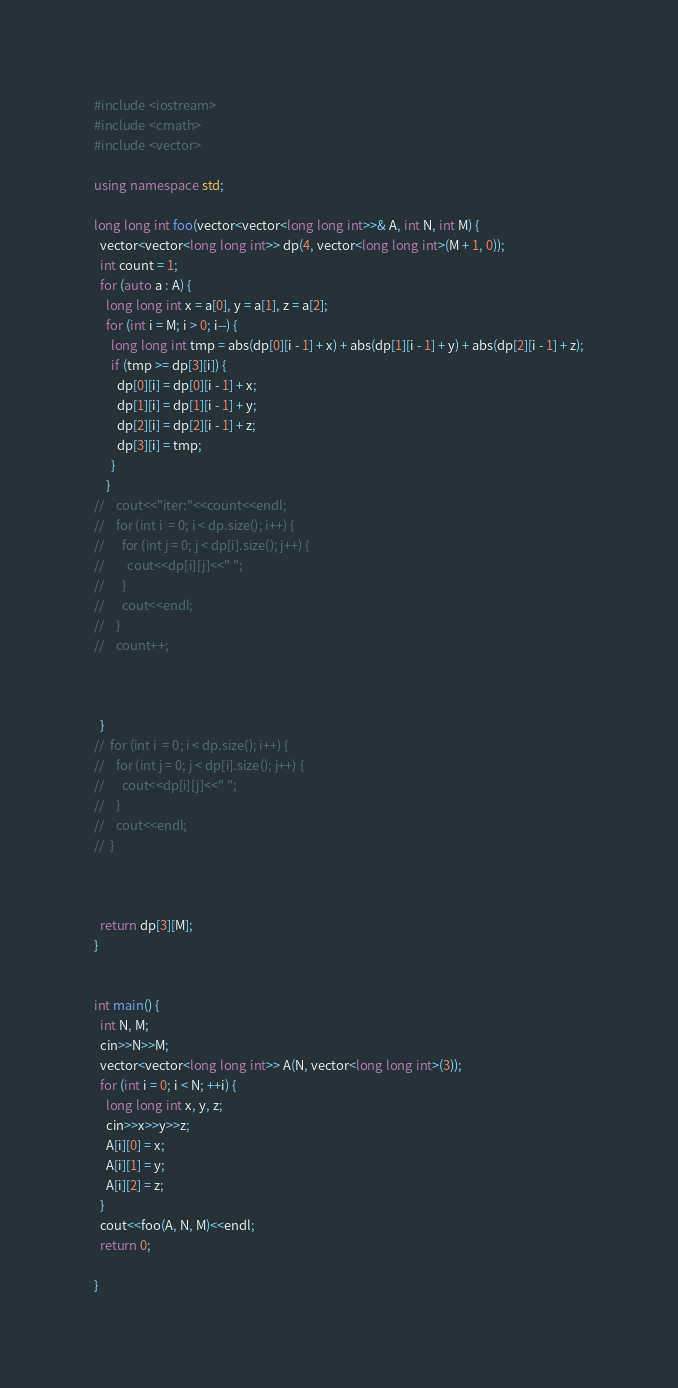<code> <loc_0><loc_0><loc_500><loc_500><_C++_>#include <iostream>
#include <cmath>
#include <vector>

using namespace std;

long long int foo(vector<vector<long long int>>& A, int N, int M) {
  vector<vector<long long int>> dp(4, vector<long long int>(M + 1, 0));
  int count = 1;
  for (auto a : A) {
    long long int x = a[0], y = a[1], z = a[2];
    for (int i = M; i > 0; i--) {
      long long int tmp = abs(dp[0][i - 1] + x) + abs(dp[1][i - 1] + y) + abs(dp[2][i - 1] + z);
      if (tmp >= dp[3][i]) {
        dp[0][i] = dp[0][i - 1] + x;
        dp[1][i] = dp[1][i - 1] + y;
        dp[2][i] = dp[2][i - 1] + z;
        dp[3][i] = tmp;
      }
    }
//    cout<<"iter:"<<count<<endl;
//    for (int i  = 0; i < dp.size(); i++) {
//      for (int j = 0; j < dp[i].size(); j++) {
//        cout<<dp[i][j]<<" ";
//      }
//      cout<<endl;
//    }
//    count++;
    
    
    
  }
//  for (int i  = 0; i < dp.size(); i++) {
//    for (int j = 0; j < dp[i].size(); j++) {
//      cout<<dp[i][j]<<" ";
//    }
//    cout<<endl;
//  }
  
  
  
  return dp[3][M];
}


int main() {
  int N, M;
  cin>>N>>M;
  vector<vector<long long int>> A(N, vector<long long int>(3));
  for (int i = 0; i < N; ++i) {
    long long int x, y, z;
    cin>>x>>y>>z;
    A[i][0] = x;
    A[i][1] = y;
    A[i][2] = z;
  }
  cout<<foo(A, N, M)<<endl;
  return 0;
    
}
</code> 